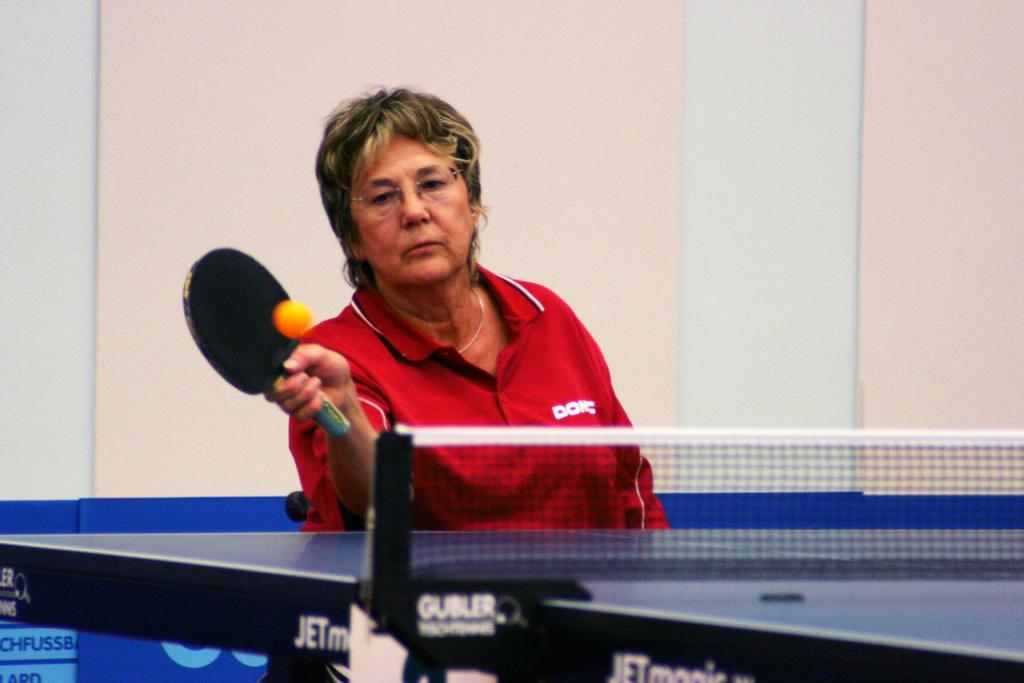What is the main subject of the image? The main subject of the image is a woman. What activity is the woman engaged in? The woman is playing table tennis. What color is the t-shirt the woman is wearing? The woman is wearing a red t-shirt. What type of army vehicle can be seen in the image? There is no army vehicle present in the image. What route is the woman taking while playing table tennis? The image does not provide information about a specific route the woman is taking while playing table tennis. 